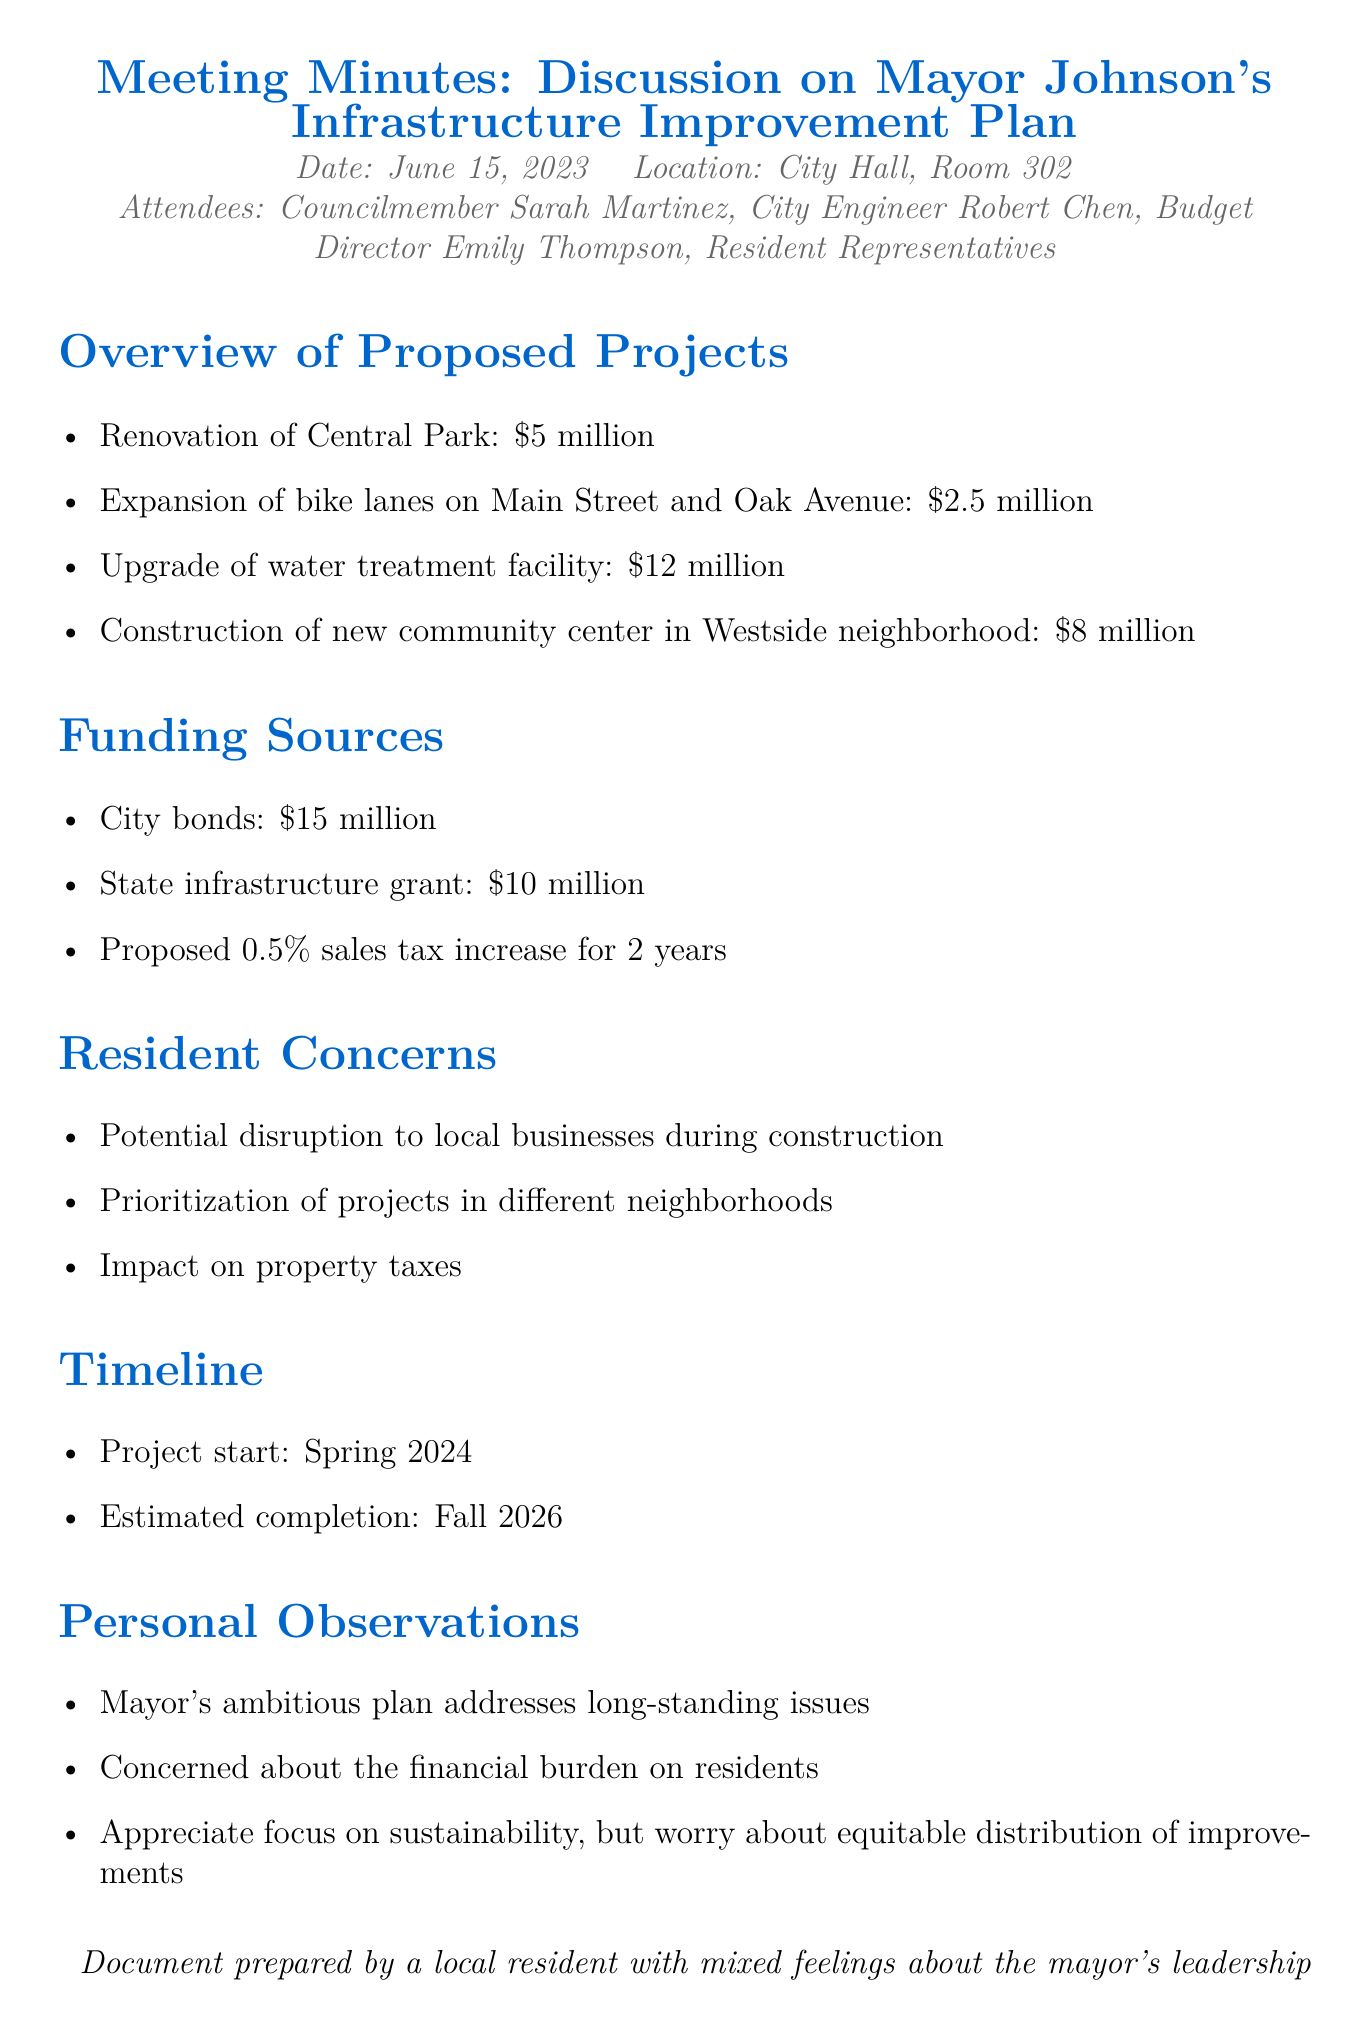What is the total estimated cost of the proposed projects? The total estimated cost is calculated by adding the cost of all proposed projects listed in the document: $5 million + $2.5 million + $12 million + $8 million = $27.5 million.
Answer: $27.5 million When is the project expected to start? The document states that the project start is scheduled for Spring 2024.
Answer: Spring 2024 What is the proposed sales tax increase percentage for funding? The document mentions a proposed 0.5% sales tax increase for funding the projects.
Answer: 0.5% What are the main resident concerns listed? The document lists concerns such as potential disruption to local businesses, prioritization of projects, and impact on property taxes.
Answer: Potential disruption to local businesses during construction, prioritization of projects in different neighborhoods, impact on property taxes Who is the Budget Director mentioned in the meeting? The document names Emily Thompson as the Budget Director attending the meeting.
Answer: Emily Thompson Why are residents concerned about the infrastructure improvement plan? Residents are concerned about the financial burden on them and potential disruptions during construction.
Answer: Financial burden on residents, potential disruption to local businesses during construction 